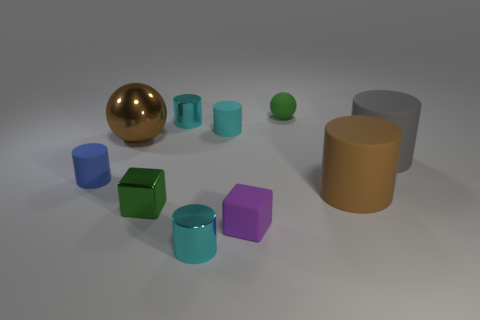Subtract all gray spheres. How many cyan cylinders are left? 3 Subtract 3 cylinders. How many cylinders are left? 3 Subtract all gray cylinders. How many cylinders are left? 5 Subtract all large cylinders. How many cylinders are left? 4 Subtract all green cylinders. Subtract all blue spheres. How many cylinders are left? 6 Subtract all spheres. How many objects are left? 8 Add 7 small cyan things. How many small cyan things are left? 10 Add 6 tiny blocks. How many tiny blocks exist? 8 Subtract 0 cyan cubes. How many objects are left? 10 Subtract all blue shiny cylinders. Subtract all tiny blue matte cylinders. How many objects are left? 9 